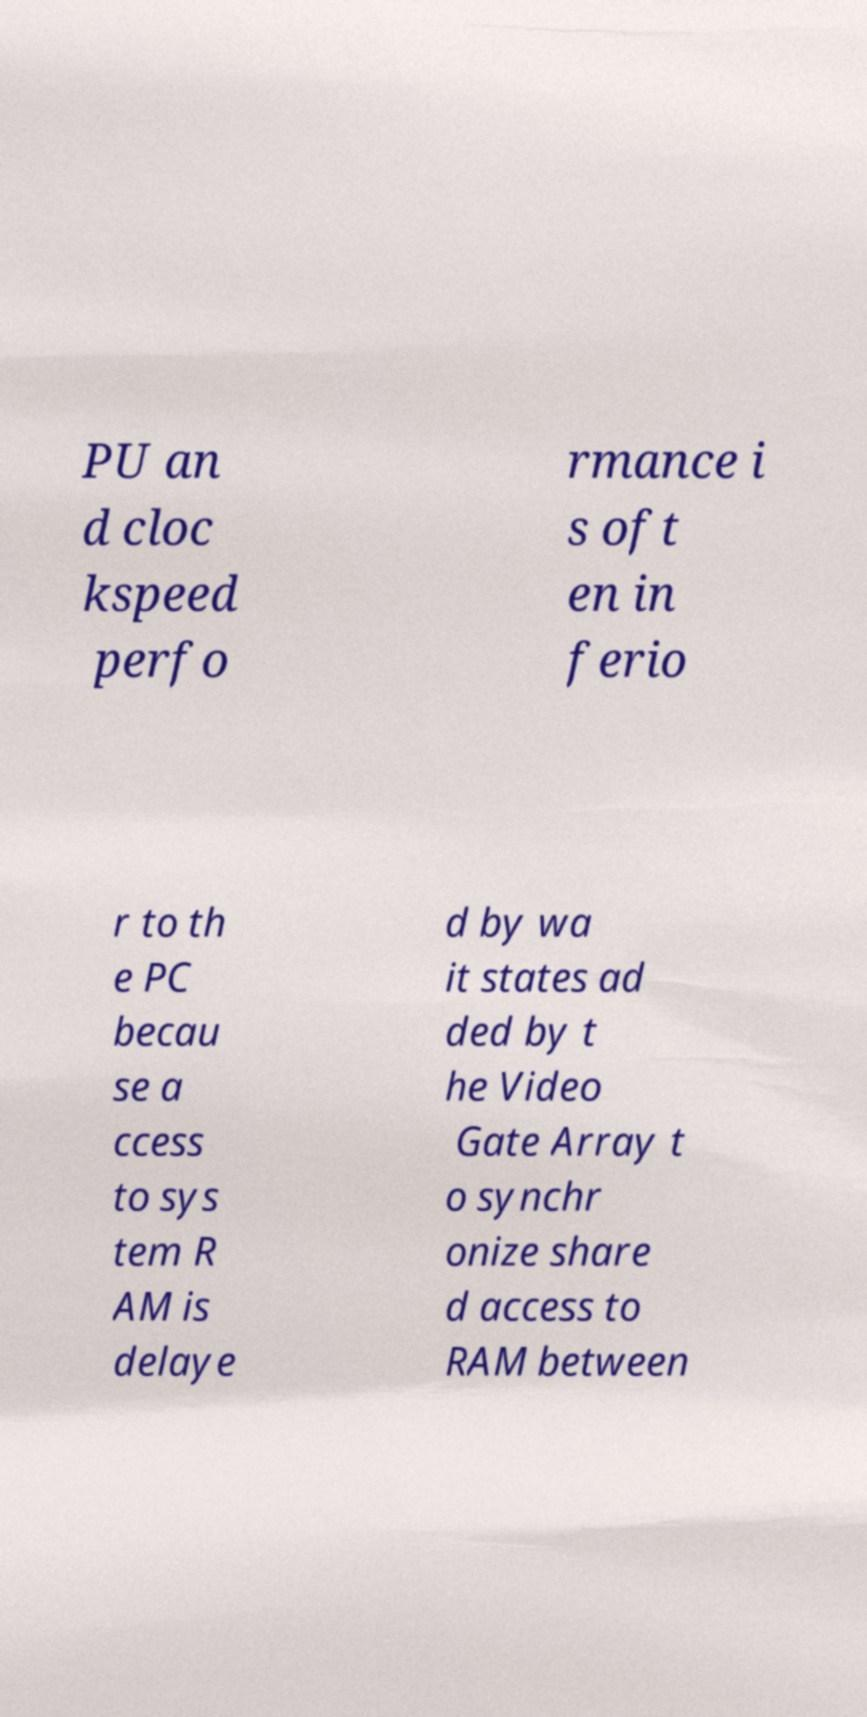Can you read and provide the text displayed in the image?This photo seems to have some interesting text. Can you extract and type it out for me? PU an d cloc kspeed perfo rmance i s oft en in ferio r to th e PC becau se a ccess to sys tem R AM is delaye d by wa it states ad ded by t he Video Gate Array t o synchr onize share d access to RAM between 